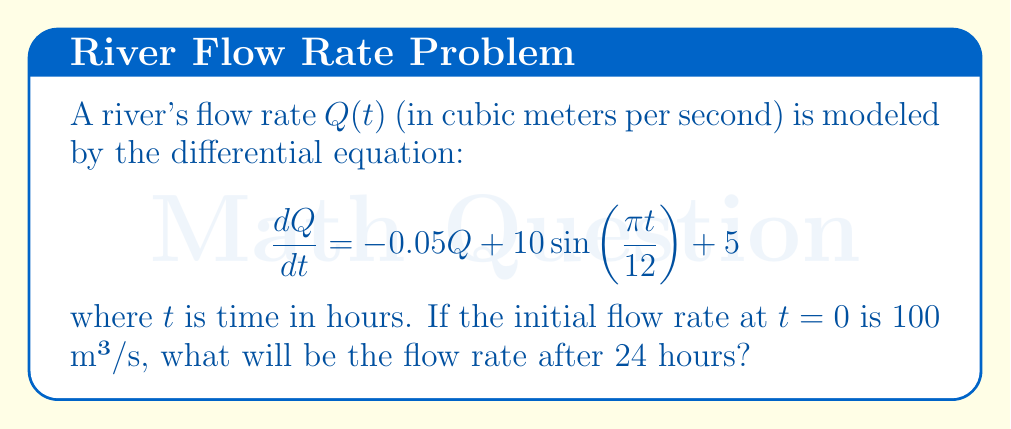Provide a solution to this math problem. To solve this first-order linear differential equation, we can use the integrating factor method:

1) The equation is in the form $\frac{dQ}{dt} + 0.05Q = 10\sin(\frac{\pi t}{12}) + 5$

2) The integrating factor is $e^{\int 0.05 dt} = e^{0.05t}$

3) Multiply both sides by the integrating factor:

   $e^{0.05t}\frac{dQ}{dt} + 0.05e^{0.05t}Q = e^{0.05t}(10\sin(\frac{\pi t}{12}) + 5)$

4) The left side is now the derivative of $e^{0.05t}Q$, so we can integrate both sides:

   $e^{0.05t}Q = \int e^{0.05t}(10\sin(\frac{\pi t}{12}) + 5)dt$

5) Integrate the right side:

   $e^{0.05t}Q = 10\int e^{0.05t}\sin(\frac{\pi t}{12})dt + 5\int e^{0.05t}dt + C$

   $= 10\frac{e^{0.05t}(0.05\sin(\frac{\pi t}{12}) + \frac{\pi}{12}\cos(\frac{\pi t}{12}))}{0.05^2 + (\frac{\pi}{12})^2} + 100e^{0.05t} + C$

6) Solve for Q:

   $Q = 10\frac{0.05\sin(\frac{\pi t}{12}) + \frac{\pi}{12}\cos(\frac{\pi t}{12})}{0.05^2 + (\frac{\pi}{12})^2} + 100 + Ce^{-0.05t}$

7) Use the initial condition $Q(0) = 100$ to find C:

   $100 = 10\frac{\frac{\pi}{12}}{0.05^2 + (\frac{\pi}{12})^2} + 100 + C$

   $C = -10\frac{\frac{\pi}{12}}{0.05^2 + (\frac{\pi}{12})^2} \approx -78.54$

8) The final solution is:

   $Q(t) = 10\frac{0.05\sin(\frac{\pi t}{12}) + \frac{\pi}{12}\cos(\frac{\pi t}{12})}{0.05^2 + (\frac{\pi}{12})^2} + 100 - 78.54e^{-0.05t}$

9) Evaluate at t = 24:

   $Q(24) = 10\frac{0.05\sin(2\pi) + \frac{\pi}{12}\cos(2\pi)}{0.05^2 + (\frac{\pi}{12})^2} + 100 - 78.54e^{-1.2}$
Answer: $Q(24) \approx 123.43$ m³/s 